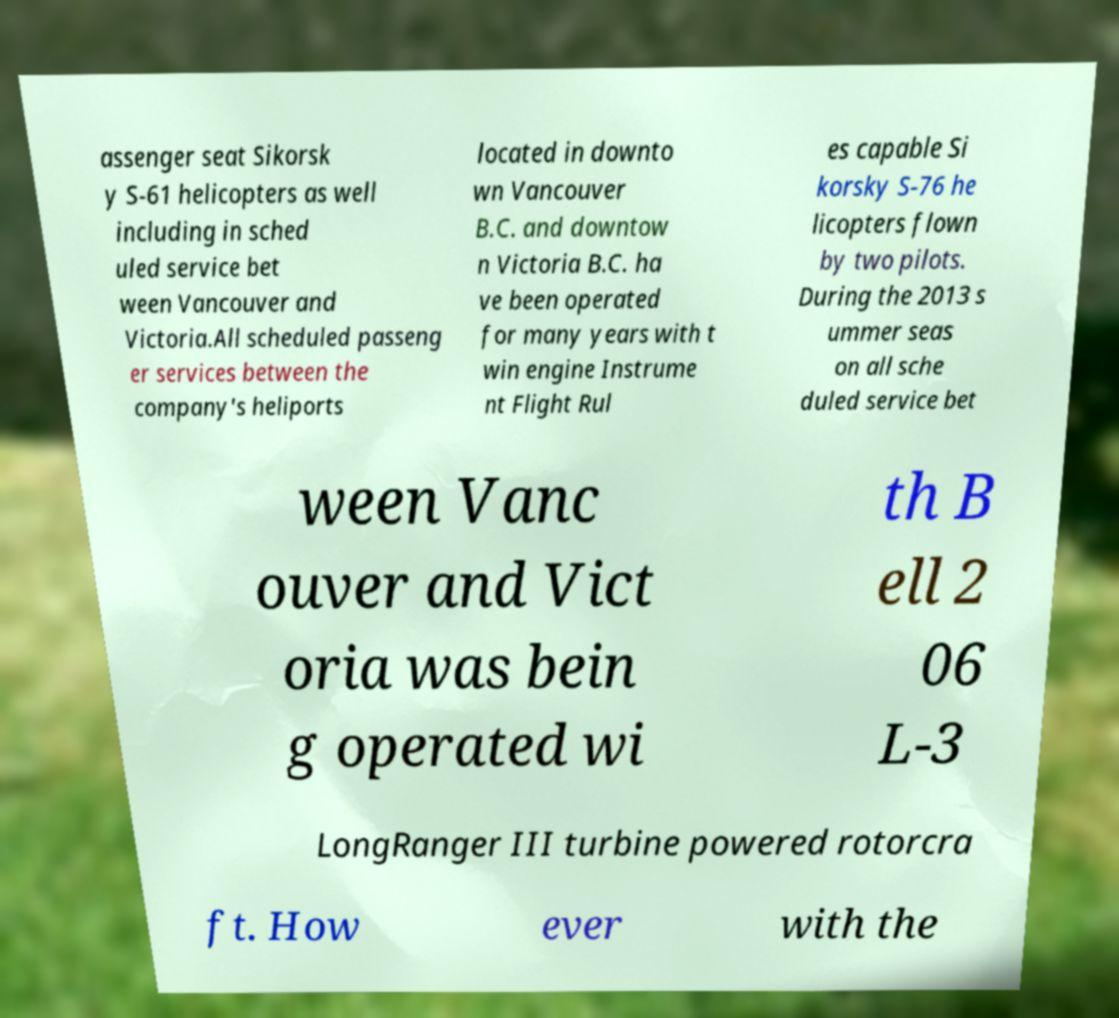I need the written content from this picture converted into text. Can you do that? assenger seat Sikorsk y S-61 helicopters as well including in sched uled service bet ween Vancouver and Victoria.All scheduled passeng er services between the company's heliports located in downto wn Vancouver B.C. and downtow n Victoria B.C. ha ve been operated for many years with t win engine Instrume nt Flight Rul es capable Si korsky S-76 he licopters flown by two pilots. During the 2013 s ummer seas on all sche duled service bet ween Vanc ouver and Vict oria was bein g operated wi th B ell 2 06 L-3 LongRanger III turbine powered rotorcra ft. How ever with the 